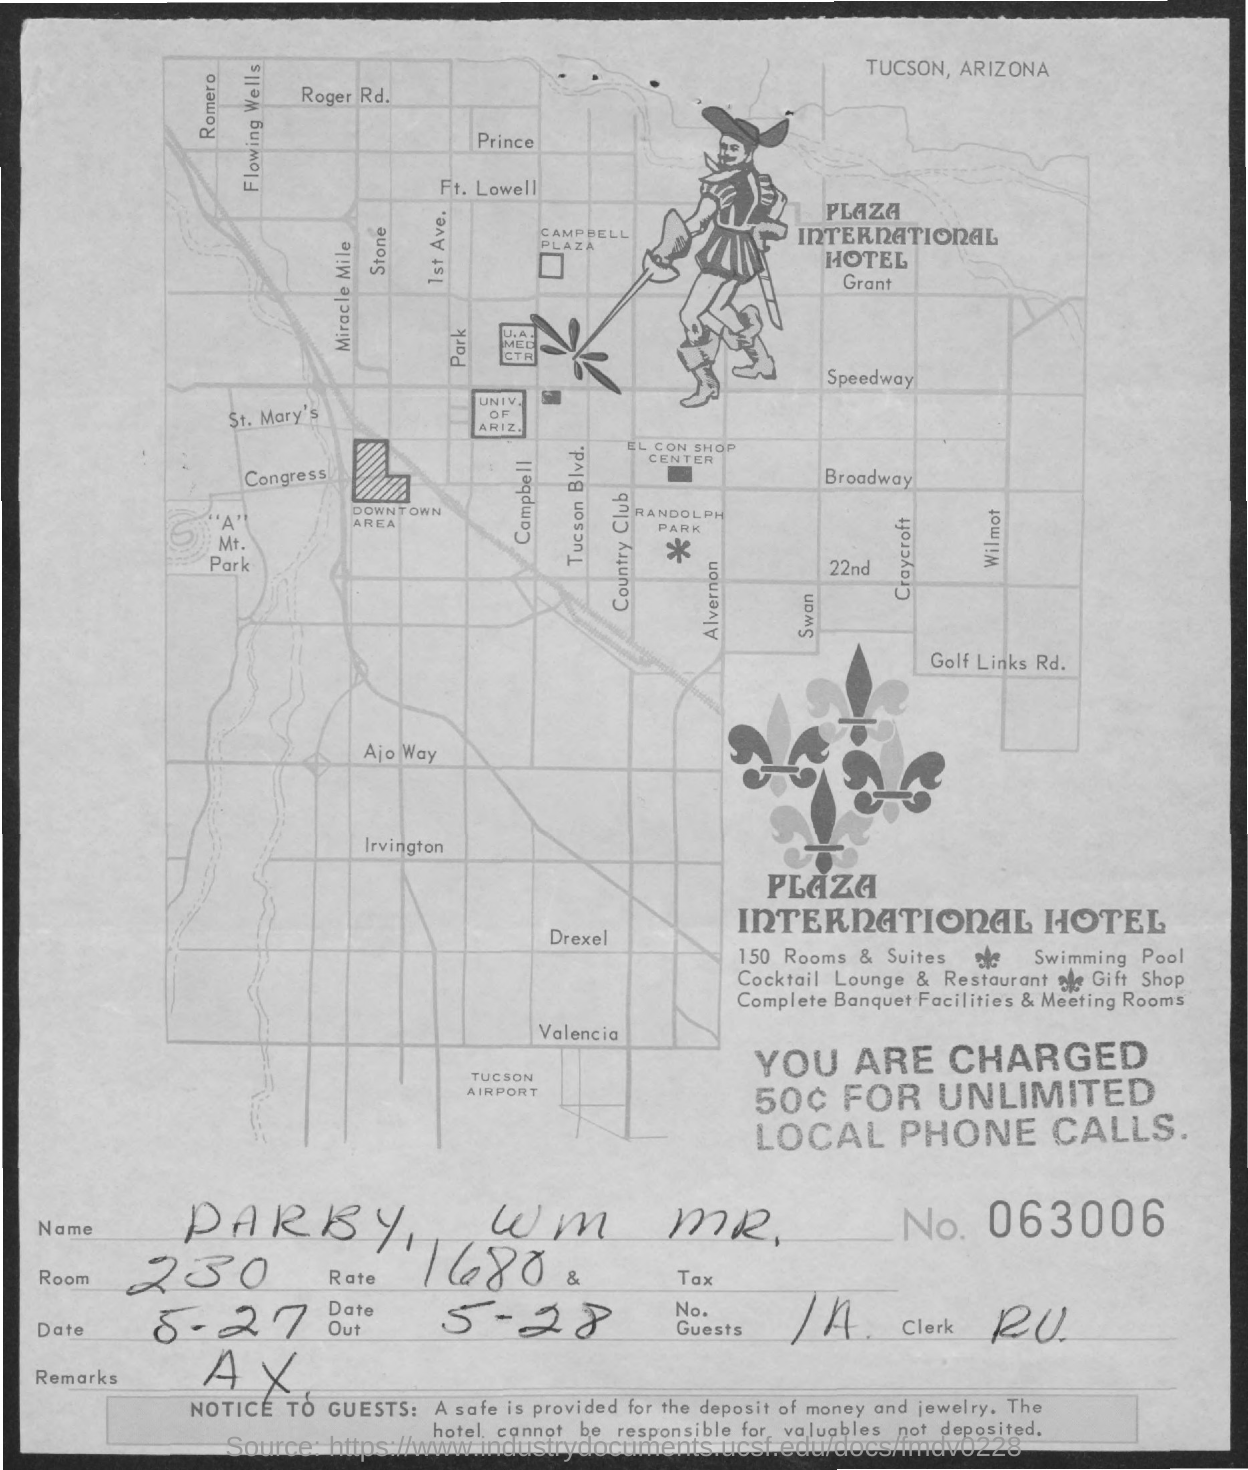What is the name of the hotel?
Offer a very short reply. PLAZA INTERNATIONAL HOTEL. What is the room number?
Give a very brief answer. 230. What is the document number?
Give a very brief answer. 063006. 